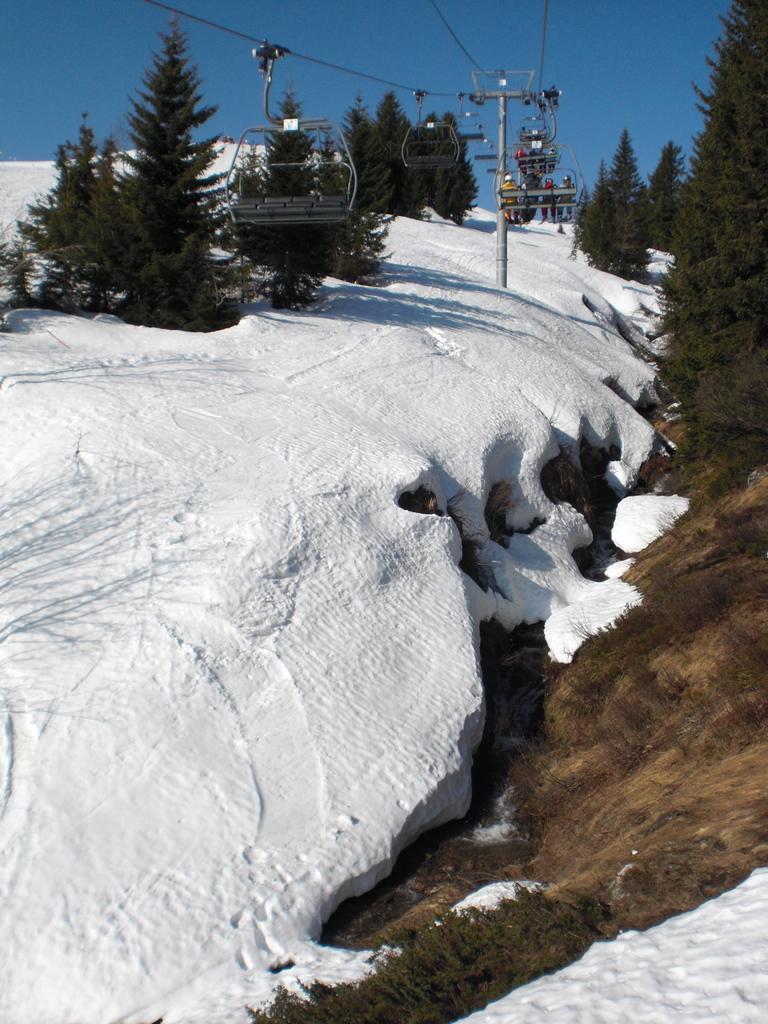In one or two sentences, can you explain what this image depicts? In this image I can see ground full of snow. I can also see number of trees, rope ways, wires, a pole and in the background I can see the sky. 